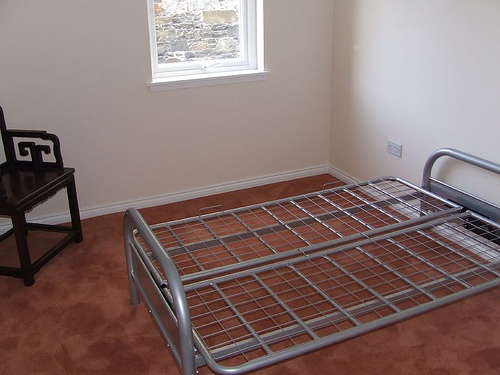<image>What color is the bedding? There is no bedding in the image. What color is the bedding? There is no bedding in the image. 